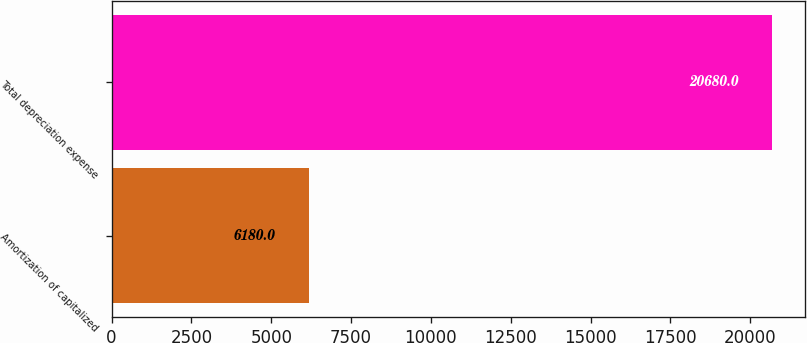Convert chart to OTSL. <chart><loc_0><loc_0><loc_500><loc_500><bar_chart><fcel>Amortization of capitalized<fcel>Total depreciation expense<nl><fcel>6180<fcel>20680<nl></chart> 